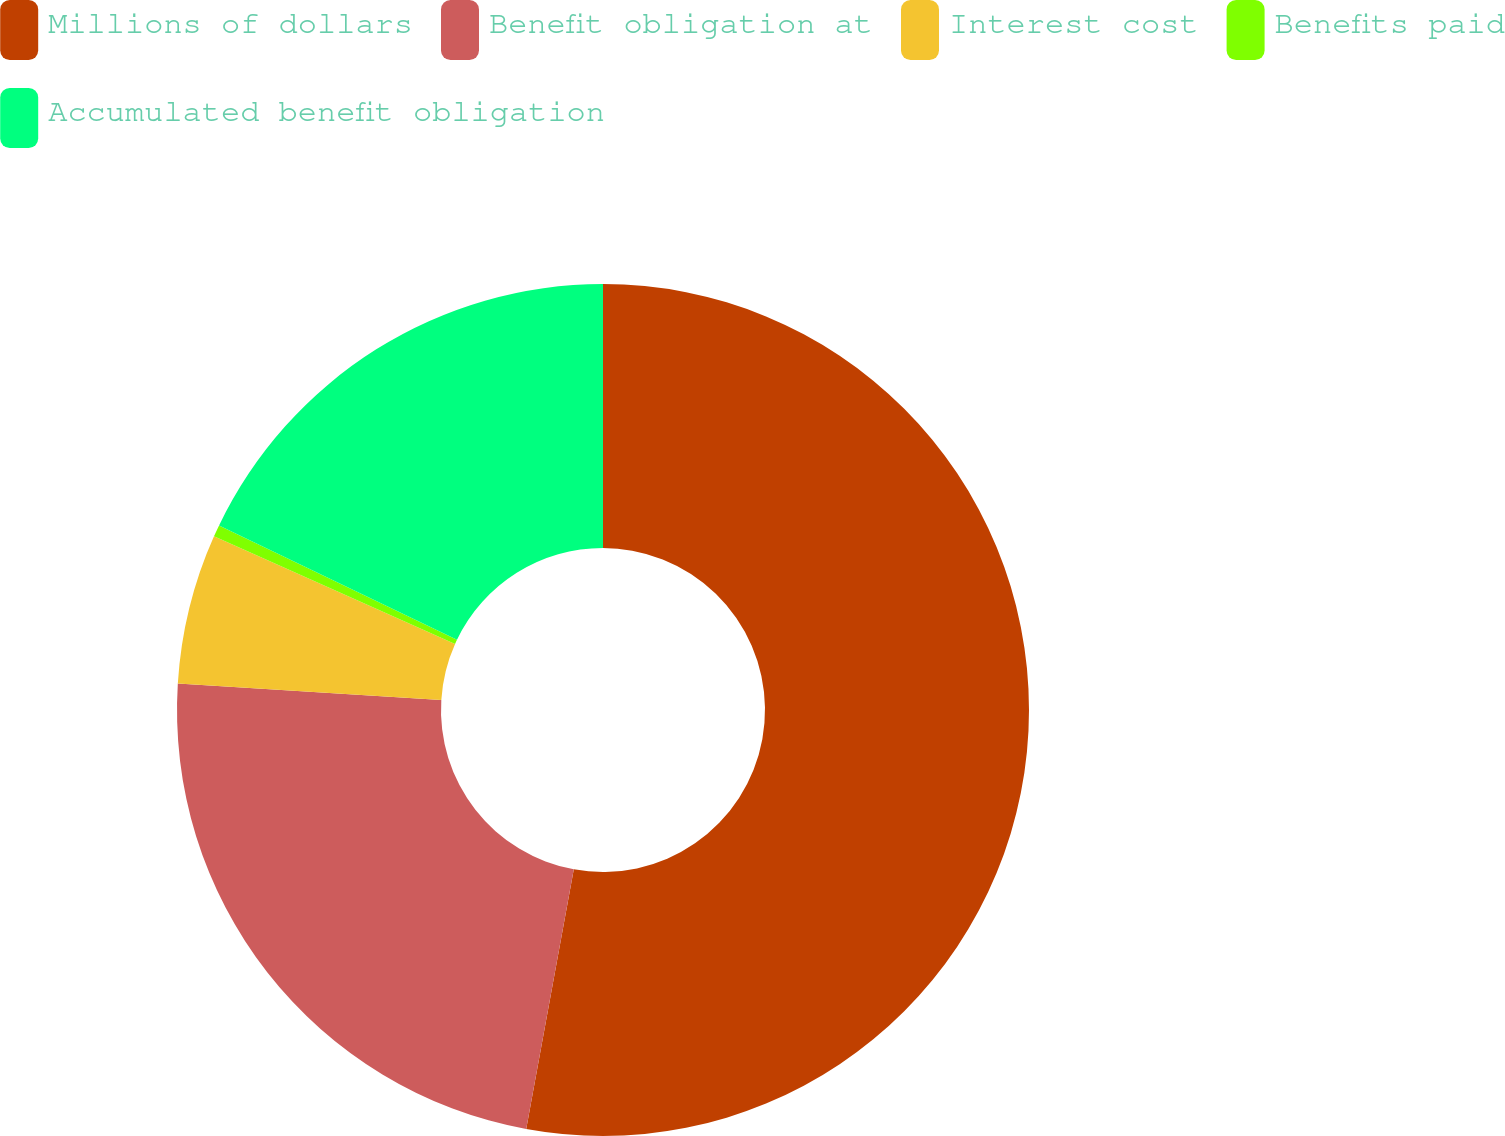<chart> <loc_0><loc_0><loc_500><loc_500><pie_chart><fcel>Millions of dollars<fcel>Benefit obligation at<fcel>Interest cost<fcel>Benefits paid<fcel>Accumulated benefit obligation<nl><fcel>52.89%<fcel>23.11%<fcel>5.69%<fcel>0.45%<fcel>17.87%<nl></chart> 